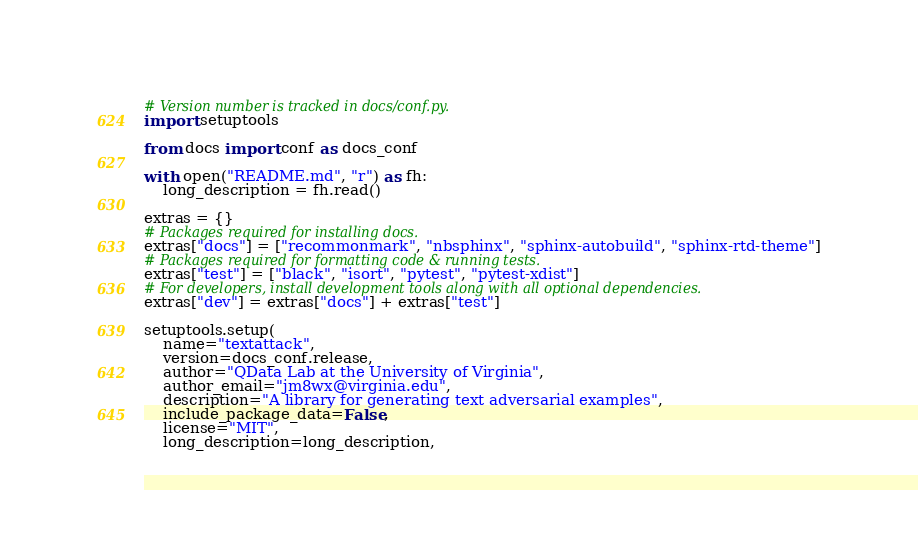<code> <loc_0><loc_0><loc_500><loc_500><_Python_># Version number is tracked in docs/conf.py.
import setuptools

from docs import conf as docs_conf

with open("README.md", "r") as fh:
    long_description = fh.read()

extras = {}
# Packages required for installing docs.
extras["docs"] = ["recommonmark", "nbsphinx", "sphinx-autobuild", "sphinx-rtd-theme"]
# Packages required for formatting code & running tests.
extras["test"] = ["black", "isort", "pytest", "pytest-xdist"]
# For developers, install development tools along with all optional dependencies.
extras["dev"] = extras["docs"] + extras["test"]

setuptools.setup(
    name="textattack",
    version=docs_conf.release,
    author="QData Lab at the University of Virginia",
    author_email="jm8wx@virginia.edu",
    description="A library for generating text adversarial examples",
    include_package_data=False,
    license="MIT",
    long_description=long_description,</code> 